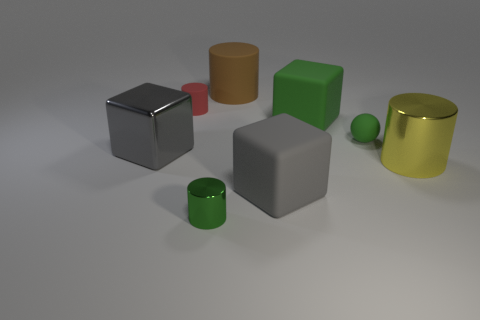Are any big cyan matte blocks visible?
Make the answer very short. No. Is there a large cube that is to the right of the tiny green object in front of the big shiny thing right of the small red rubber cylinder?
Keep it short and to the point. Yes. How many big things are matte cylinders or yellow rubber blocks?
Your answer should be very brief. 1. The shiny cylinder that is the same size as the brown object is what color?
Make the answer very short. Yellow. There is a large green matte object; how many tiny green things are left of it?
Your answer should be very brief. 1. Is there a gray sphere made of the same material as the small green sphere?
Your response must be concise. No. There is a large object that is the same color as the ball; what is its shape?
Provide a succinct answer. Cube. What color is the small thing that is in front of the yellow shiny cylinder?
Provide a succinct answer. Green. Is the number of small matte balls left of the yellow cylinder the same as the number of large metallic blocks behind the large brown rubber cylinder?
Your response must be concise. No. There is a large cube on the right side of the big gray block that is to the right of the green shiny object; what is it made of?
Your answer should be very brief. Rubber. 